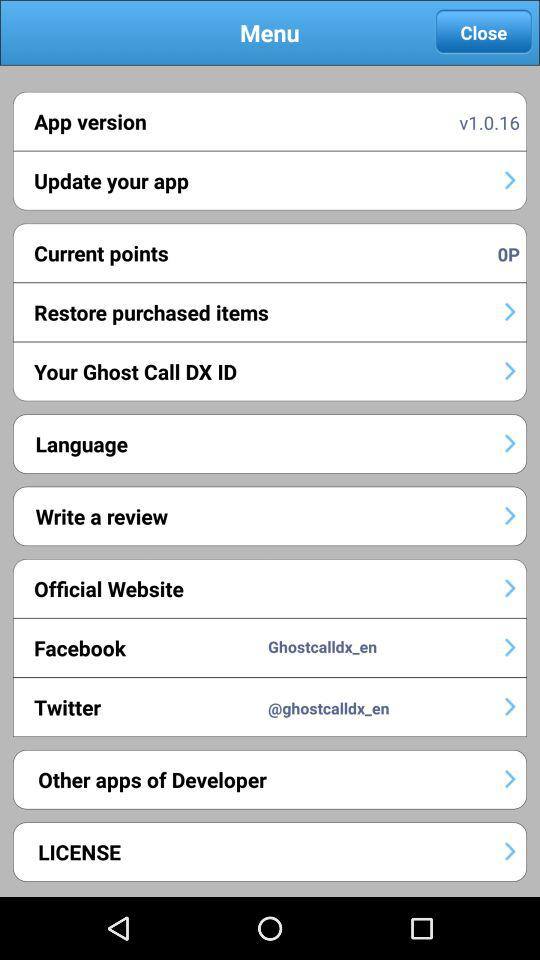How many points are there? There are 0 points. 